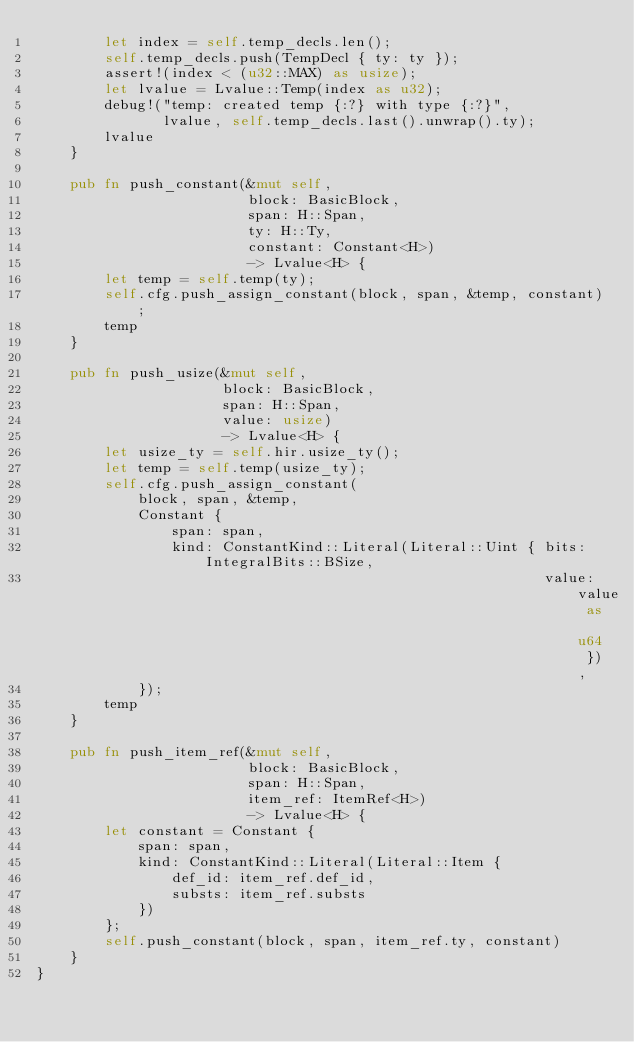Convert code to text. <code><loc_0><loc_0><loc_500><loc_500><_Rust_>        let index = self.temp_decls.len();
        self.temp_decls.push(TempDecl { ty: ty });
        assert!(index < (u32::MAX) as usize);
        let lvalue = Lvalue::Temp(index as u32);
        debug!("temp: created temp {:?} with type {:?}",
               lvalue, self.temp_decls.last().unwrap().ty);
        lvalue
    }

    pub fn push_constant(&mut self,
                         block: BasicBlock,
                         span: H::Span,
                         ty: H::Ty,
                         constant: Constant<H>)
                         -> Lvalue<H> {
        let temp = self.temp(ty);
        self.cfg.push_assign_constant(block, span, &temp, constant);
        temp
    }

    pub fn push_usize(&mut self,
                      block: BasicBlock,
                      span: H::Span,
                      value: usize)
                      -> Lvalue<H> {
        let usize_ty = self.hir.usize_ty();
        let temp = self.temp(usize_ty);
        self.cfg.push_assign_constant(
            block, span, &temp,
            Constant {
                span: span,
                kind: ConstantKind::Literal(Literal::Uint { bits: IntegralBits::BSize,
                                                            value: value as u64 }),
            });
        temp
    }

    pub fn push_item_ref(&mut self,
                         block: BasicBlock,
                         span: H::Span,
                         item_ref: ItemRef<H>)
                         -> Lvalue<H> {
        let constant = Constant {
            span: span,
            kind: ConstantKind::Literal(Literal::Item {
                def_id: item_ref.def_id,
                substs: item_ref.substs
            })
        };
        self.push_constant(block, span, item_ref.ty, constant)
    }
}
</code> 